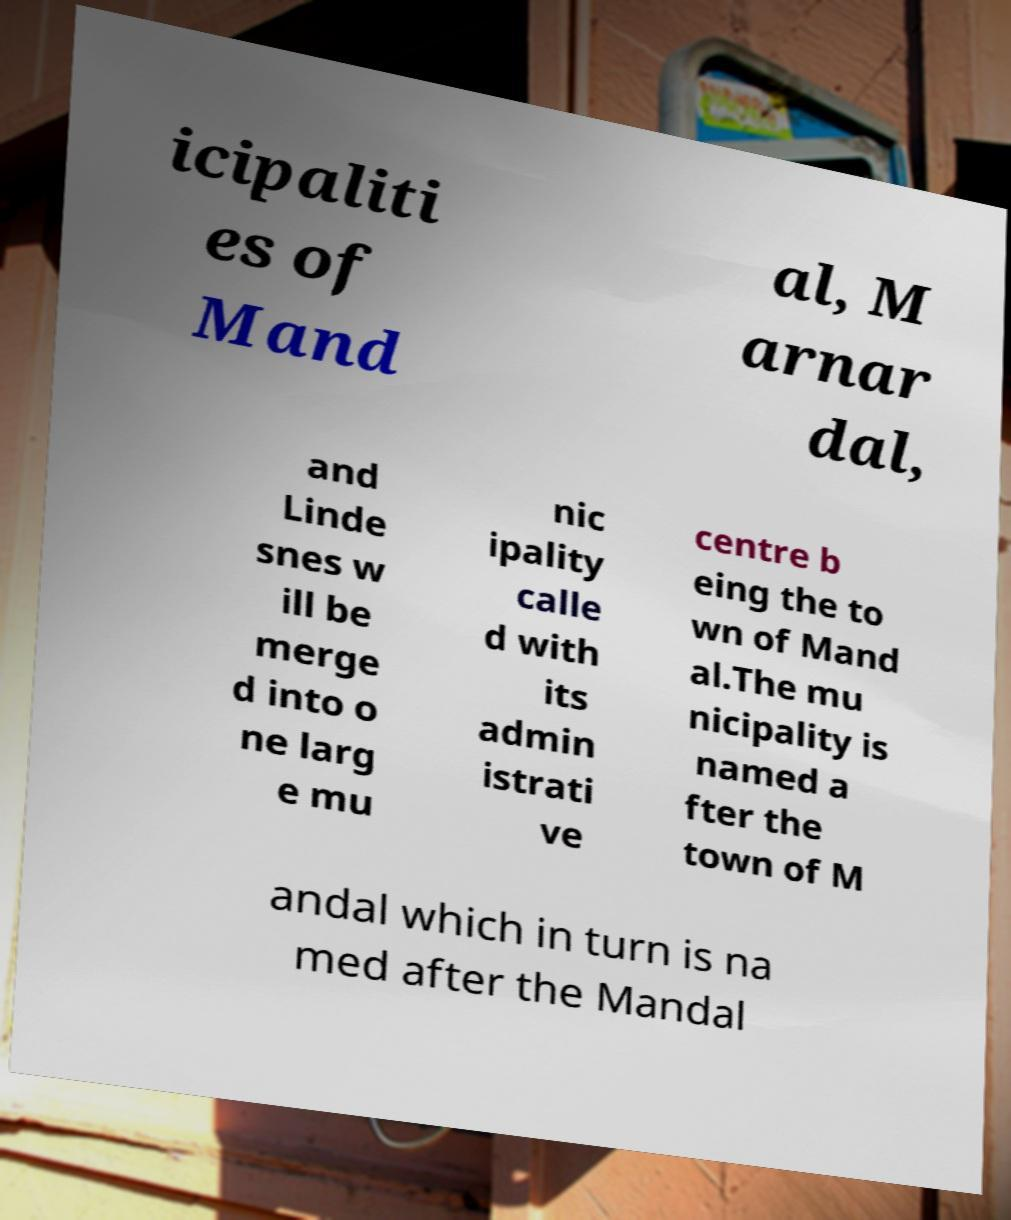For documentation purposes, I need the text within this image transcribed. Could you provide that? icipaliti es of Mand al, M arnar dal, and Linde snes w ill be merge d into o ne larg e mu nic ipality calle d with its admin istrati ve centre b eing the to wn of Mand al.The mu nicipality is named a fter the town of M andal which in turn is na med after the Mandal 